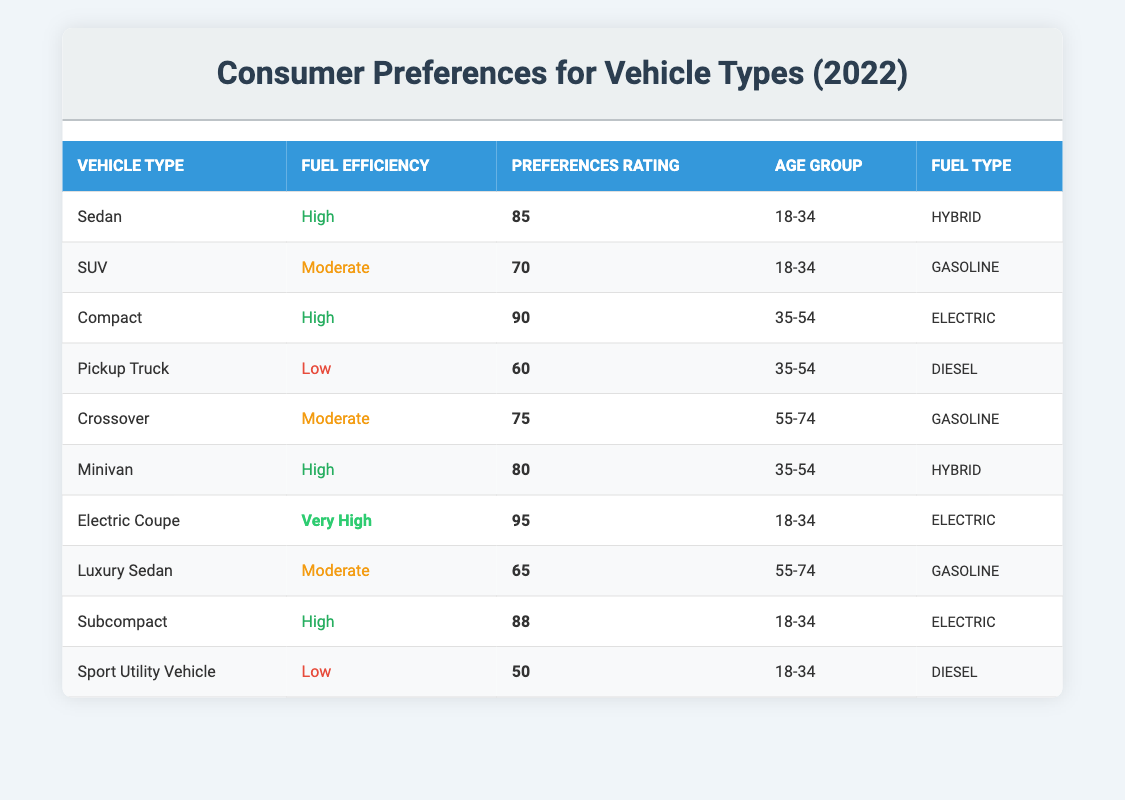What is the highest preferences rating among vehicle types? To find the highest preferences rating, we scan through the "Preferences Rating" column and identify the maximum value among the ratings. The highest value is 95, which corresponds to the "Electric Coupe."
Answer: 95 Which age group prefers the Sedan vehicle type? By examining the table, we see that the "Sedan" is listed under the "Age Group" column with the value "18-34."
Answer: 18-34 What is the average preferences rating for vehicles with high fuel efficiency? We identify the vehicles with "High" fuel efficiency, which are the Sedan, Compact, Minivan, and Subcompact, with ratings of 85, 90, 80, and 88 respectively. To find the average, we calculate (85 + 90 + 80 + 88) = 343 and then divide by the number of vehicles: 343 / 4 = 85.75.
Answer: 85.75 Do any vehicles with low fuel efficiency have a preferences rating above 50? Looking at the "Low" fuel efficiency vehicles, we find the Pickup Truck with a rating of 60 and the Sport Utility Vehicle with a rating of 50. Since the Pickup Truck has a rating above 50, the answer is yes.
Answer: Yes Which fuel type has the highest preferences ratings, and what are its associated ratings? We compare the preferences ratings for each fuel type. The "Electric" fuel type has ratings of 90 (Compact), 95 (Electric Coupe), and 88 (Subcompact), totaling 273. The "Hybrid" fuel type has ratings of 85 (Sedan) and 80 (Minivan) totaling 165. The highest preferences ratings are thus from the "Electric" fuel type.
Answer: Electric, 90, 95, 88 What is the relationship between fuel efficiency and preferences rating for the SUV and Crossover? Looking through the table, the SUV has a moderate fuel efficiency with a rating of 70, while the Crossover also has moderate fuel efficiency with a rating of 75. In both cases, the preferences ratings are similar, indicating that moderate fuel efficiency results in comparable preferences ratings for these types.
Answer: Moderate, 70 and 75 Which vehicle type has the lowest preferences rating and what is its fuel efficiency? The lowest preferences rating observed is for the "Sport Utility Vehicle" with a rating of 50, which is classified as having low fuel efficiency.
Answer: Sport Utility Vehicle, Low Are there any vehicles with a preferences rating of 80 or more that use gasoline? By reviewing the table, the only vehicles that use gasoline are the SUV (70), Crossover (75), and Luxury Sedan (65) — none of which have a rating of 80 or above. Therefore, the answer is no.
Answer: No How many vehicle types have very high fuel efficiency and what are their preferences ratings? We check the table for entries showing "Very High" fuel efficiency, which is represented by only the "Electric Coupe" at a rating of 95. Counting this entry yields a total of one vehicle type.
Answer: 1, Electric Coupe, 95 